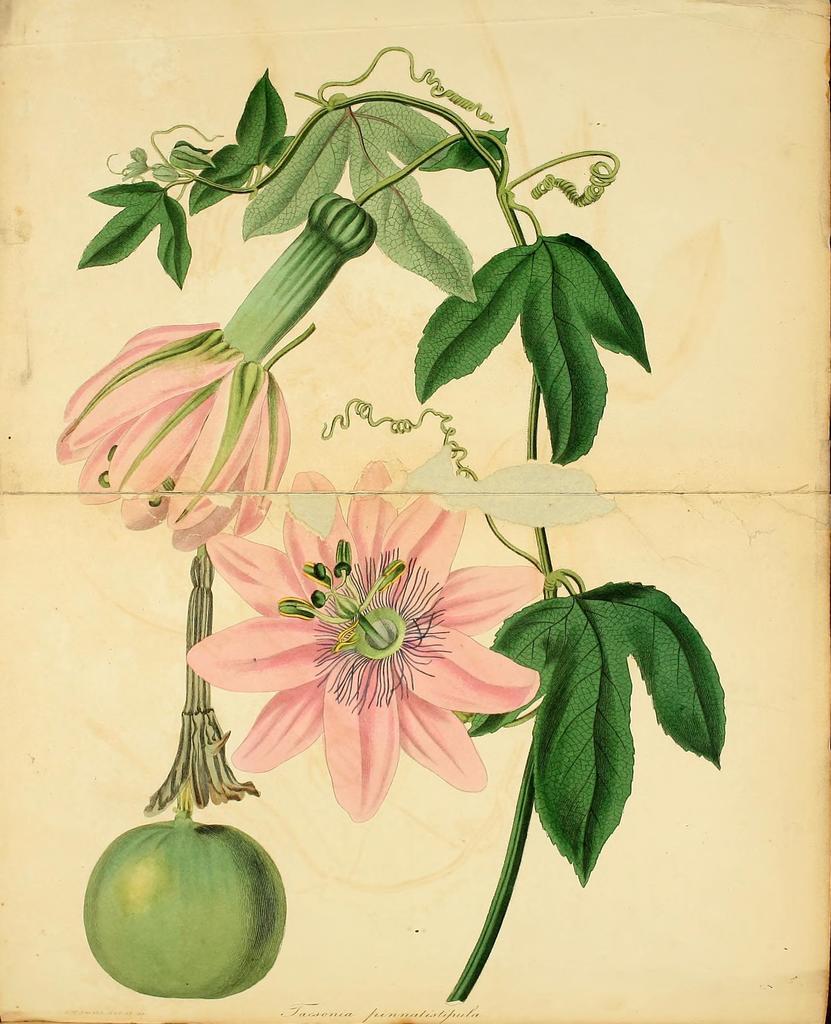In one or two sentences, can you explain what this image depicts? In this picture I can see a paper. There are words and there is an image of flowers, leaves and a fruit or a vegetable on the paper. 